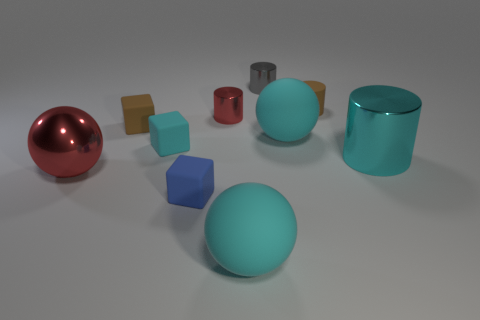Subtract all blocks. How many objects are left? 7 Add 6 tiny metal objects. How many tiny metal objects exist? 8 Subtract 1 red spheres. How many objects are left? 9 Subtract all metallic objects. Subtract all brown things. How many objects are left? 4 Add 4 red metal spheres. How many red metal spheres are left? 5 